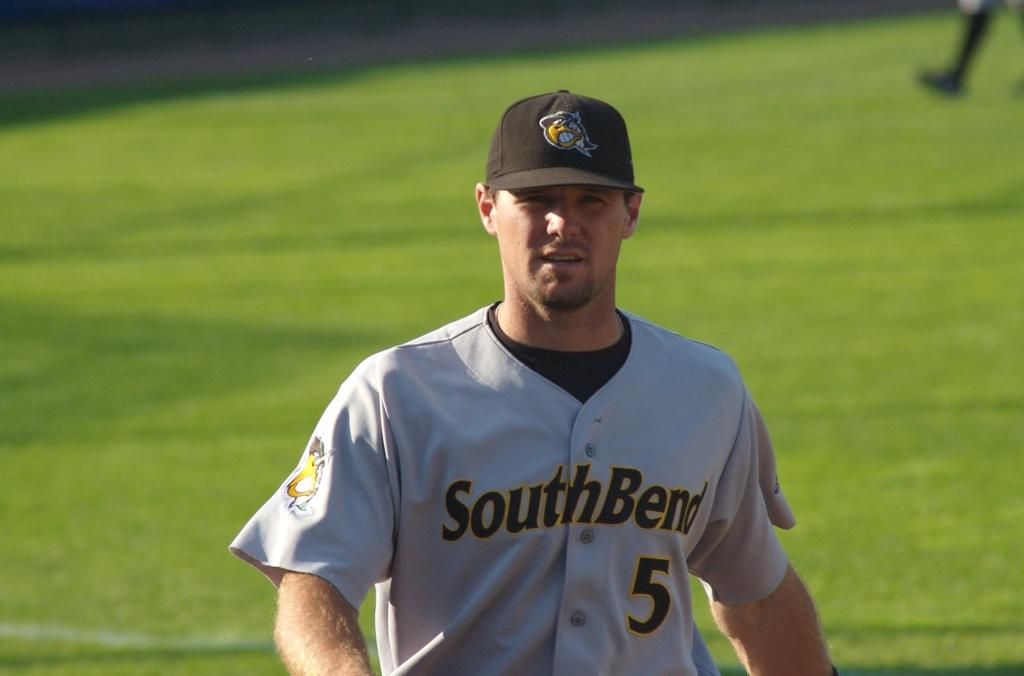<image>
Write a terse but informative summary of the picture. Baseball player with a South Bend uniform and ball cap on. 